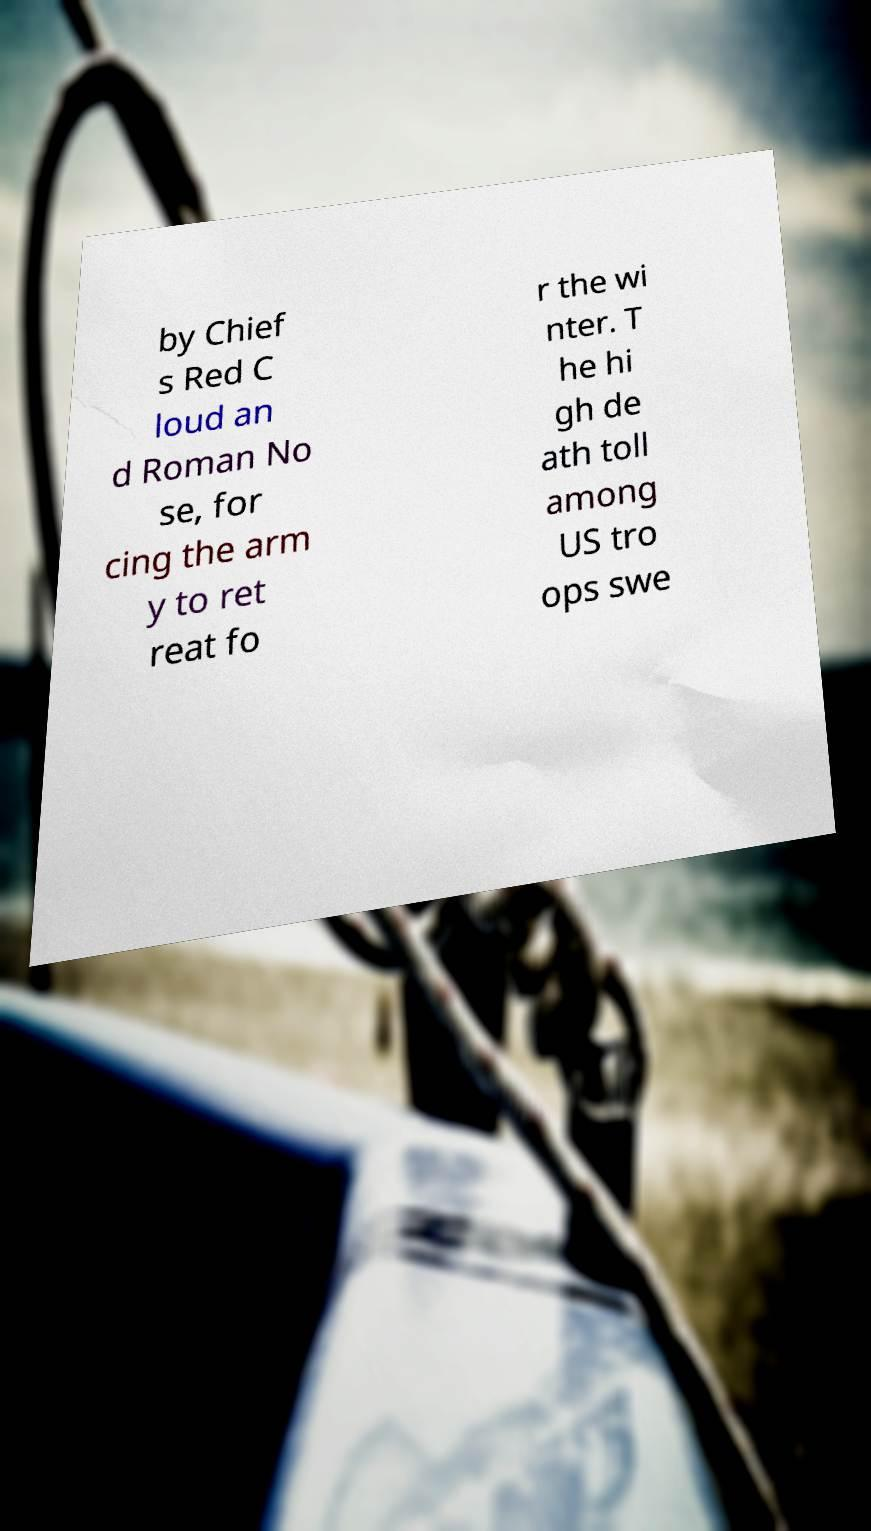Could you assist in decoding the text presented in this image and type it out clearly? by Chief s Red C loud an d Roman No se, for cing the arm y to ret reat fo r the wi nter. T he hi gh de ath toll among US tro ops swe 